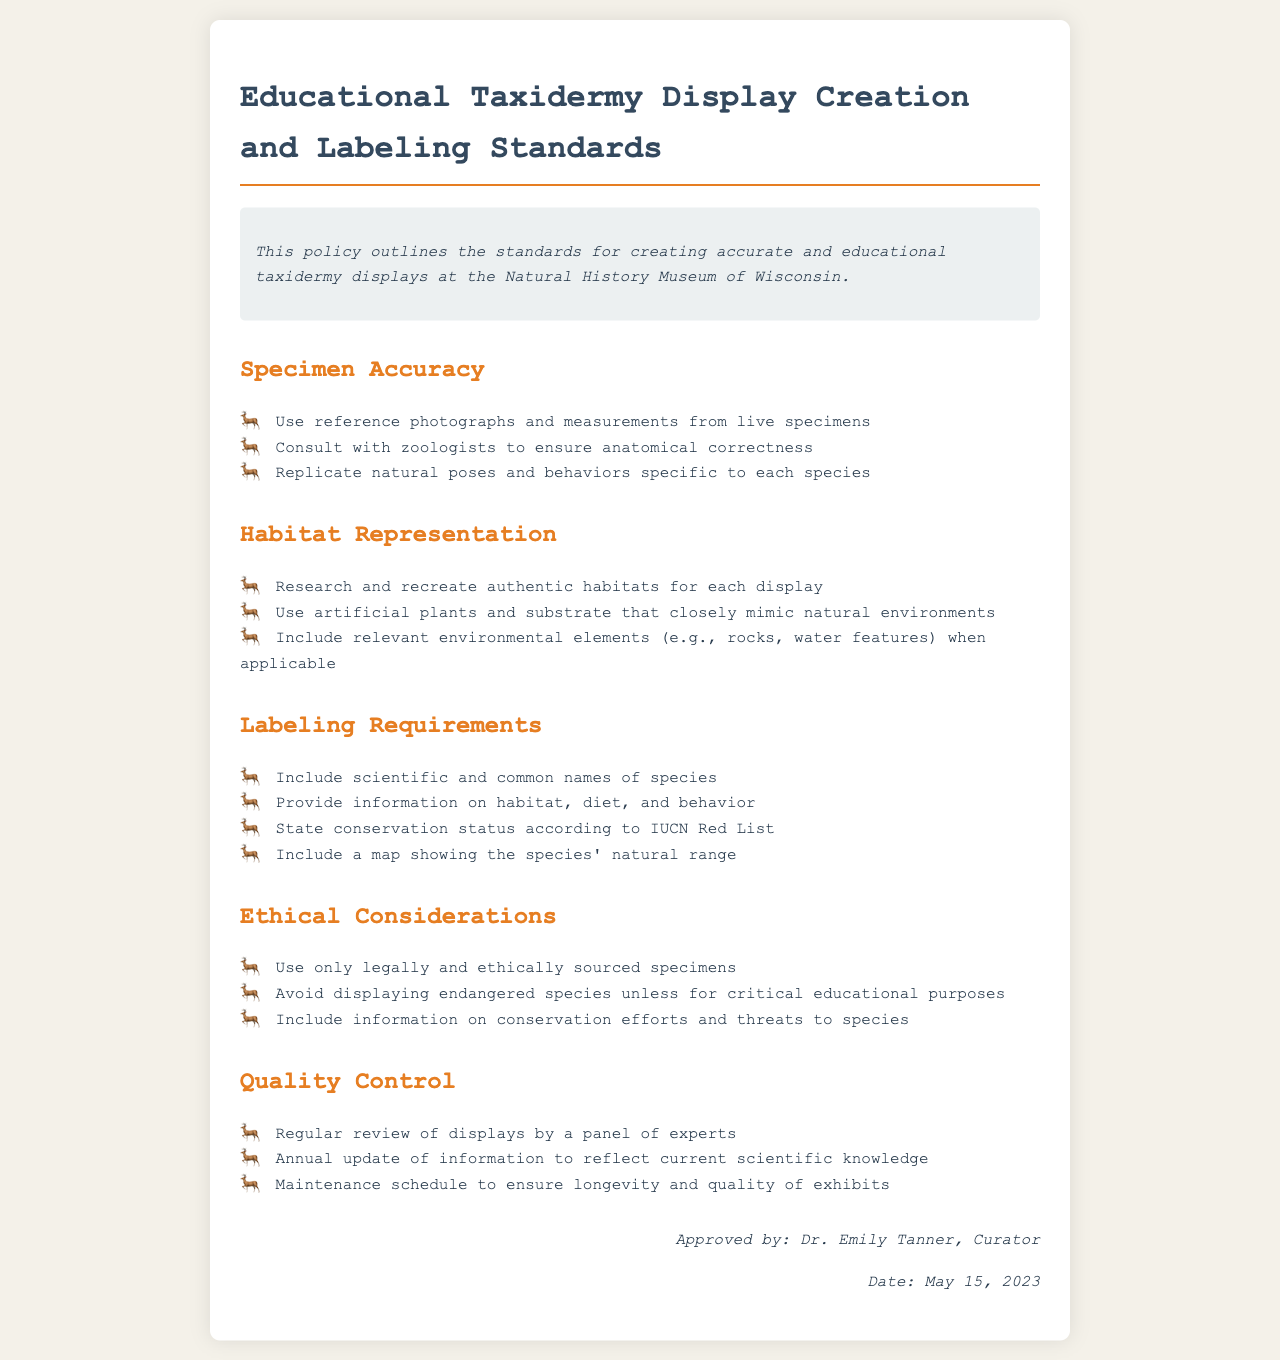What is the title of the policy document? The title is prominently displayed at the top of the document, indicating the subject matter.
Answer: Educational Taxidermy Display Creation and Labeling Standards Who approved the document? The document includes an approval section that specifies the individual who sanctioned the policy.
Answer: Dr. Emily Tanner What date was the policy approved? The approved date is included in the approval section of the document for reference.
Answer: May 15, 2023 What must be included in the labeling requirements? The document lists specific criteria under the labeling requirements that need to be fulfilled for educational displays.
Answer: Scientific and common names of species Which group should be consulted for anatomical correctness? The policy mentions a specific group of experts that should be consulted to ensure accuracy in the display.
Answer: Zoologists What should be used for habitat representation? The document outlines what materials should be used to accurately represent habitats in taxidermy displays.
Answer: Artificial plants and substrate What is stated about displaying endangered species? The policy provides a guideline regarding the ethical display of endangered species, outlining the conditions under which it is acceptable.
Answer: For critical educational purposes How often should the information in displays be updated? The document specifies how frequently the information displayed should be reviewed and updated to maintain accuracy.
Answer: Annually What type of habitats should be recreated for displays? The policy elaborates on the kind of habitats that should be represented to ensure educational accuracy.
Answer: Authentic habitats 